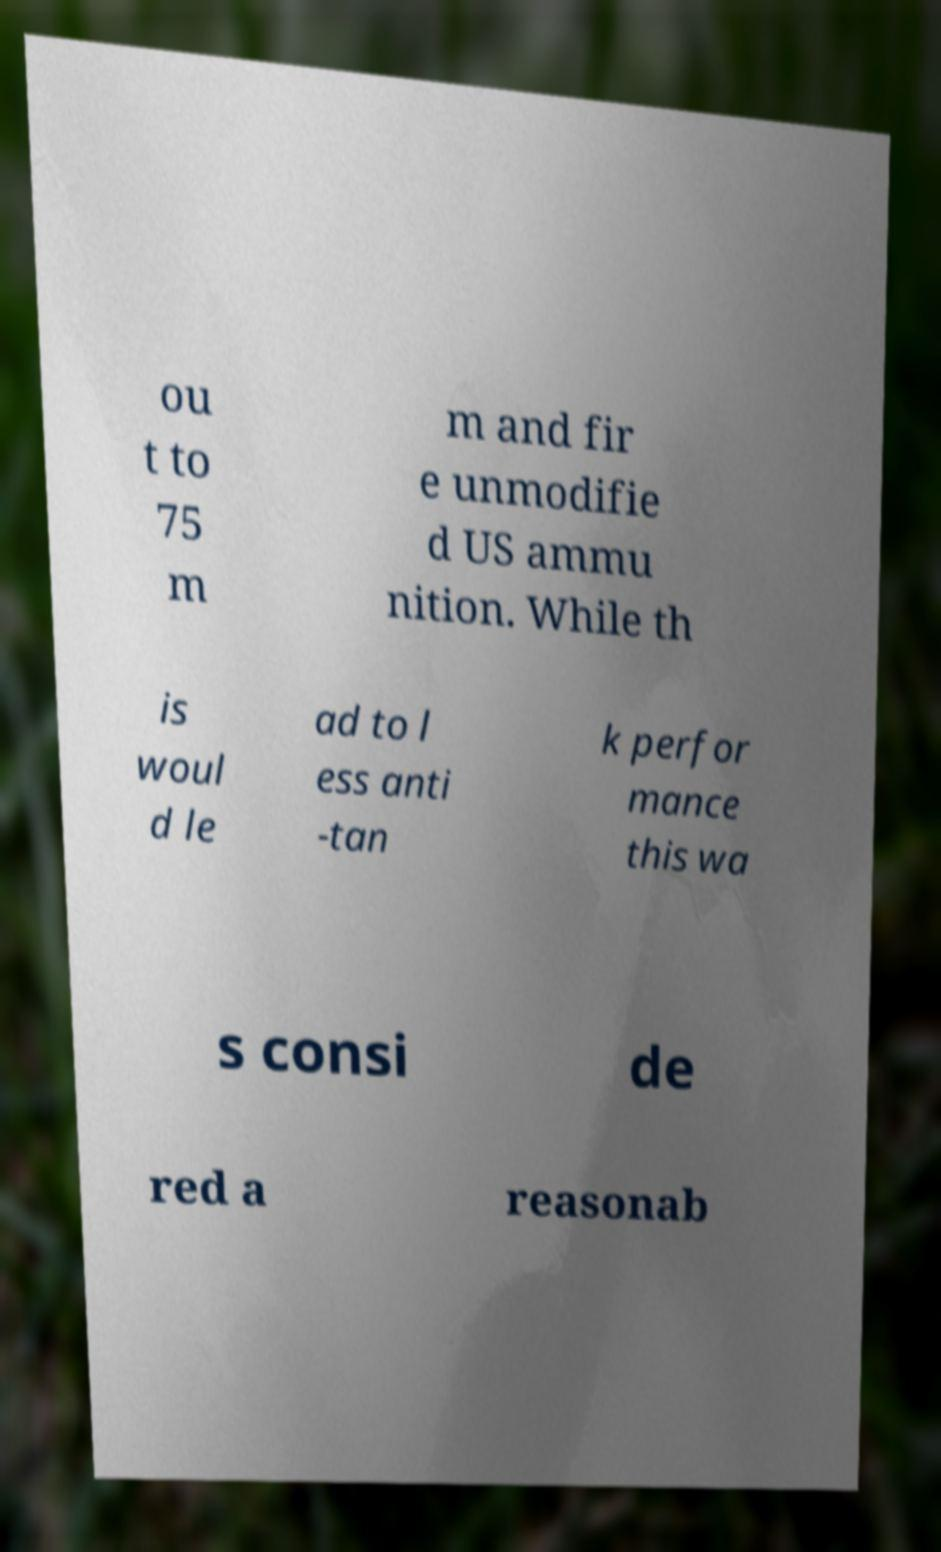There's text embedded in this image that I need extracted. Can you transcribe it verbatim? ou t to 75 m m and fir e unmodifie d US ammu nition. While th is woul d le ad to l ess anti -tan k perfor mance this wa s consi de red a reasonab 